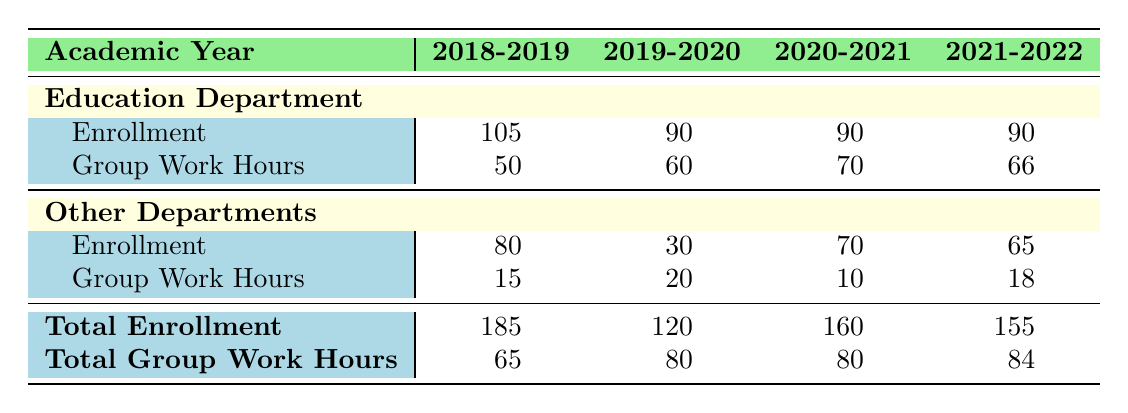What was the total enrollment in the Education department during the academic year 2018-2019? The table indicates that the total enrollment in the Education department for 2018-2019 is listed directly under the Education Department's Enrollment row. The value shown is 105.
Answer: 105 How many group work hours were allocated in total for all courses across all departments in the academic year 2020-2021? To find the total group work hours for 2020-2021, we look at the total row for Group Work Hours. The value is 80, which represents the summation of group work hours from both the Education department and other departments.
Answer: 80 Was the enrollment in the Education department higher in 2019-2020 than in 2020-2021? In the table, the enrollment for the Education department in 2019-2020 is 90, and for 2020-2021, it is also 90. Since both figures are equal, the statement is false.
Answer: No What is the difference in total group work hours between the Education department's maximum in 2020-2021 and minimum in 2018-2019? From the table, the maximum group work hours for the Education department is 70 in 2020-2021, and the minimum is 50 in 2018-2019. The difference is 70 - 50 = 20.
Answer: 20 What was the average enrollment across all departments in the academic year 2021-2022? The total enrollment for 2021-2022 is 155, which can be calculated as the sum of enrollments from both the Education department (90) and other departments (65). Since there are two departments, the average is 155 / 2 = 77.5.
Answer: 77.5 Did more students enroll in the English department or the Education department across all years? The total enrollment for the Education department across all years is 90 + 90 + 90 + 90 = 360. For the English department, there is only one year of data (30). Thus, the Education department had significantly more students enrolled.
Answer: Education department What was the average number of group work hours dedicated to courses in the Education department from 2018-2019 to 2021-2022? The total group work hours in the Education department across these years are 50 + 60 + 70 + 66 = 246. There are four academic years, so the average is 246 / 4 = 61.5.
Answer: 61.5 How does the total enrollment for the 2018-2019 academic year compare to the 2019-2020 academic year? The total enrollment for 2018-2019 is 185, while for 2019-2020 it is 120. Thus, there were 65 more students enrolled in 2018-2019 compared to 2019-2020.
Answer: 65 more students 